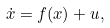<formula> <loc_0><loc_0><loc_500><loc_500>\dot { x } = { f } ( { x } ) + { u } ,</formula> 